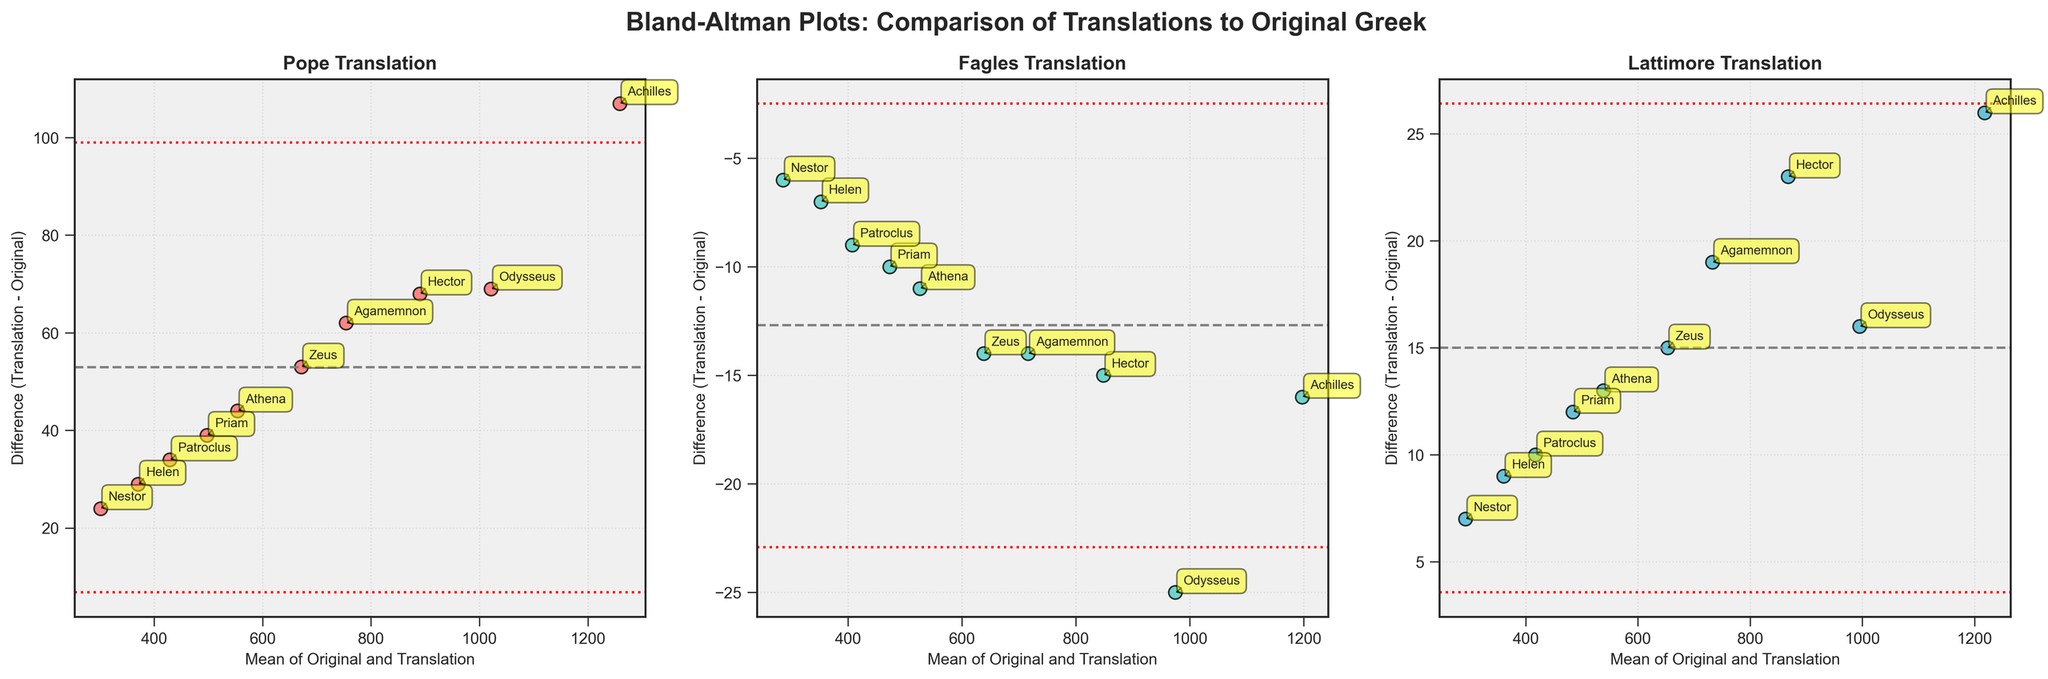What is the title of the figure? The title is written at the top of the plot, stating the purpose of the figure. It reads "Bland-Altman Plots: Comparison of Translations to Original Greek".
Answer: Bland-Altman Plots: Comparison of Translations to Original Greek How many characters from Homeric epics are represented in the plot? Each of the three subplots has the same number of scatter points, each labeled with a character's name. Counting the annotations, there are a total of 10 characters.
Answer: 10 Which translation has the smallest mean difference compared to the Original Greek? The mean difference is indicated by the gray dashed line in each subplot. The closest to zero is observed in the Fagles translation subplot.
Answer: Fagles What is the range of the differences for the Lattimore translation? The differences for each character can be seen where the points are spread vertically around zero. The range can be determined by noting the highest and lowest differences on the y-axis in the Lattimore subplot. They range approximately from -50 to +50.
Answer: -50 to +50 Which character has the largest positive difference in the Pope translation plot? The character with the largest positive difference will be the highest point above the zero line in the Pope subplot. Based on the annotations, it seems to be Achilles.
Answer: Achilles What are the mean and standard deviations (SD) of differences in the Fagles translation plot? The Bland-Altman plot provides the mean difference (dashed gray line) and the lines representing mean ± 1.96 * SD (dotted red lines). These annotations allow calculation as follows: Mean difference is around -3, ±1.96*SD lines appear to be around -50 and +44. Therefore, SD can be computed: 1.96*SD ≈ 47, thus SD ≈ 24.
Answer: Mean: -3, SD: 24 How many characters are above the mean difference line in the Lattimore translation plot? Points above the gray dashed line in the Lattimore subplot indicate characters whose differences are above the mean difference. Counting these, there are 5 such characters.
Answer: 5 Which translation shows the largest deviation from the Original Greek for the character Nestor? The spread of points farthest from the zero line in each subplot shows the largest deviation for each character. For Nestor, compare his position in all three plots. He is farthest from zero in the Pope translation subplot.
Answer: Pope What would be the upper and lower limits of agreement for the Pope translation plot? Limits of agreement are represented by the red dotted lines, calculated as mean ± 1.96*SD. For the Pope subplot, these lines are approximately at +80 and -60.
Answer: +80, -60 